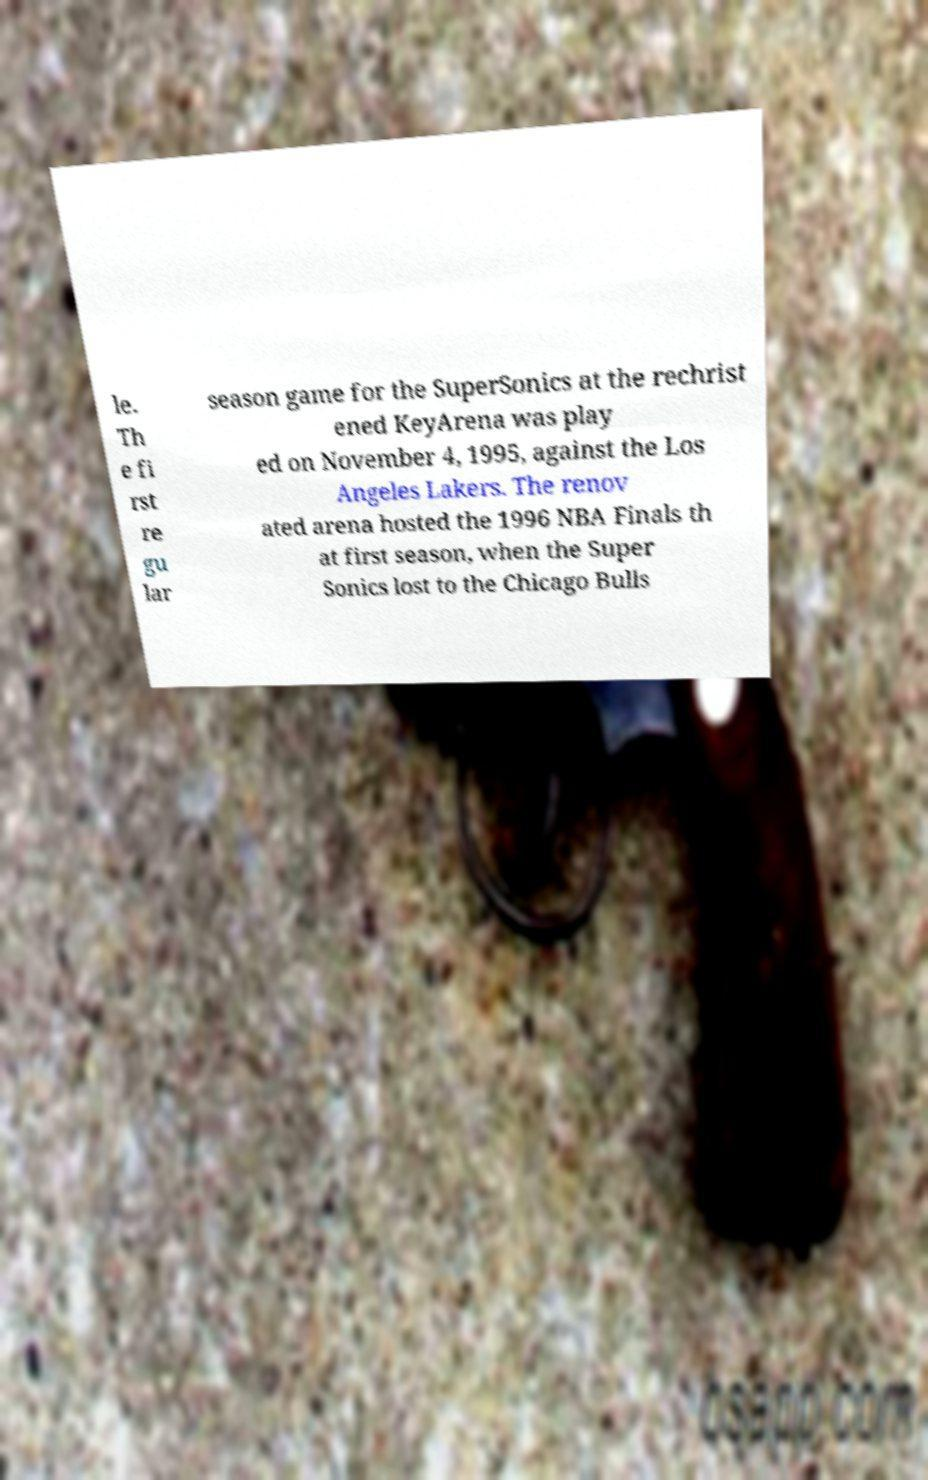For documentation purposes, I need the text within this image transcribed. Could you provide that? le. Th e fi rst re gu lar season game for the SuperSonics at the rechrist ened KeyArena was play ed on November 4, 1995, against the Los Angeles Lakers. The renov ated arena hosted the 1996 NBA Finals th at first season, when the Super Sonics lost to the Chicago Bulls 